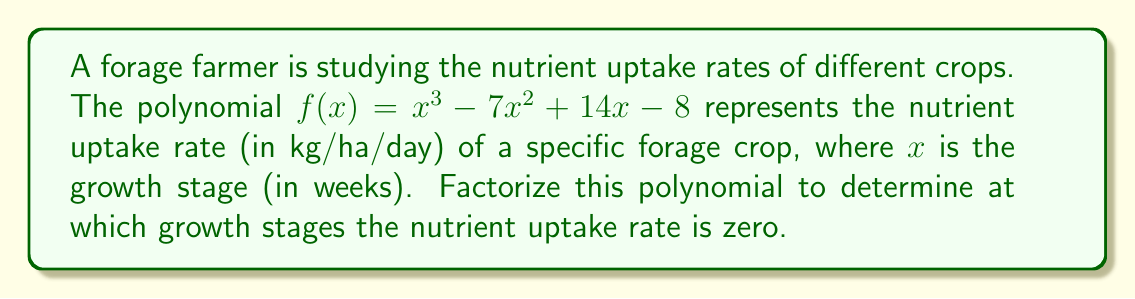Teach me how to tackle this problem. To solve this problem, we need to factorize the polynomial $f(x) = x^3 - 7x^2 + 14x - 8$ and find its roots.

Step 1: Check for rational roots using the rational root theorem.
Possible rational roots: $\pm 1, \pm 2, \pm 4, \pm 8$

Step 2: Use synthetic division to test these roots.
Testing $x = 1$:
$$
\begin{array}{r}
1 \enclose{longdiv}{1 \quad -7 \quad 14 \quad -8} \\
\underline{1 \quad -6 \quad 8} \\
1 \quad -6 \quad 8 \quad 0
\end{array}
$$

We found that $x = 1$ is a root, so $(x - 1)$ is a factor.

Step 3: Divide the original polynomial by $(x - 1)$ to get the quadratic factor.
$$f(x) = (x - 1)(x^2 - 6x + 8)$$

Step 4: Factor the quadratic term $(x^2 - 6x + 8)$.
$$(x^2 - 6x + 8) = (x - 2)(x - 4)$$

Step 5: Write the complete factorization.
$$f(x) = (x - 1)(x - 2)(x - 4)$$

Therefore, the nutrient uptake rate is zero at growth stages of 1, 2, and 4 weeks.
Answer: 1, 2, and 4 weeks 